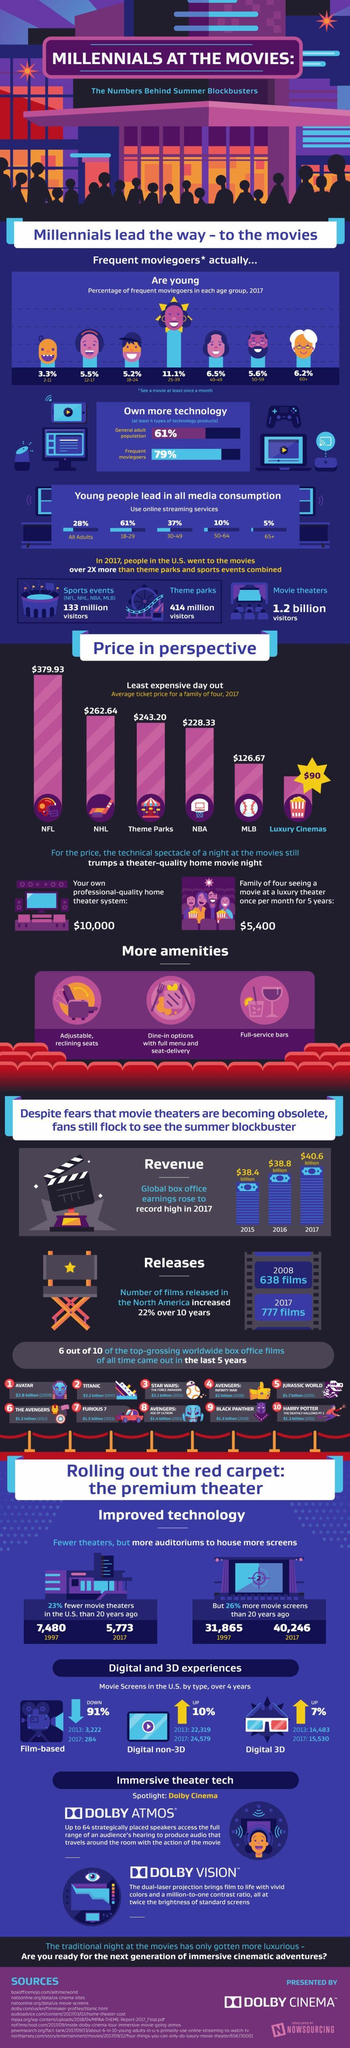What is the difference in price between NFL and NHL?
Answer the question with a short phrase. $117.29 Which age group top the frequent moviegoers graph? 25-39 Who owns more technology? Frequent moviegoers What was the revenue in 2017? $40.6 billion What percentage of youth use online streaming services? 61% What does the information mean by frequent moviegoers? See a movie at least once a month What percentage of senior citizens go for movies? 6.2% 